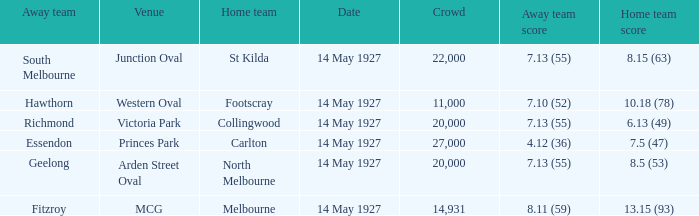Which venue hosted a home team with a score of 13.15 (93)? MCG. 